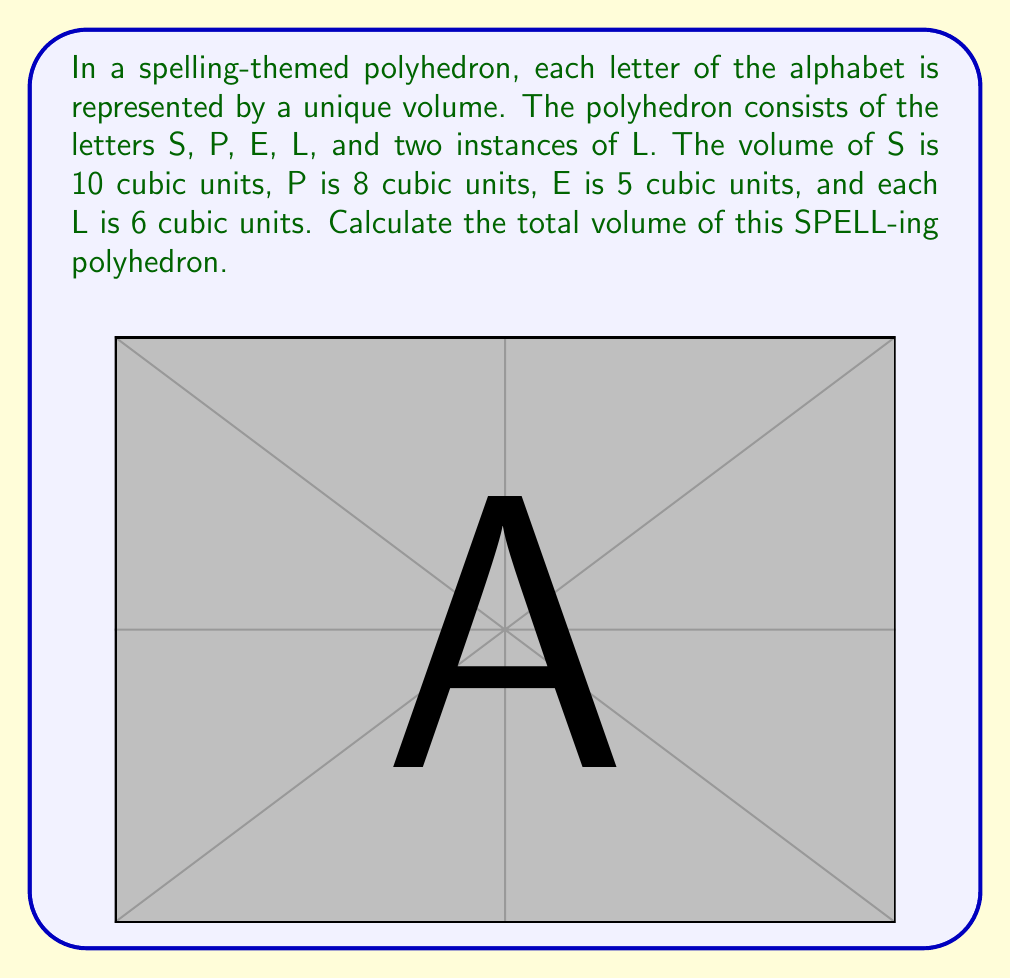Help me with this question. To calculate the volume of this unusual polyhedron, we need to sum the volumes of each component:

1. Volume of S: $V_S = 10$ cubic units
2. Volume of P: $V_P = 8$ cubic units
3. Volume of E: $V_E = 5$ cubic units
4. Volume of L (first instance): $V_{L1} = 6$ cubic units
5. Volume of L (second instance): $V_{L2} = 6$ cubic units

The total volume is the sum of all these components:

$$V_{total} = V_S + V_P + V_E + V_{L1} + V_{L2}$$

Substituting the values:

$$V_{total} = 10 + 8 + 5 + 6 + 6$$

$$V_{total} = 35$$ cubic units

Therefore, the total volume of the SPELL-ing polyhedron is 35 cubic units.
Answer: $35$ cubic units 